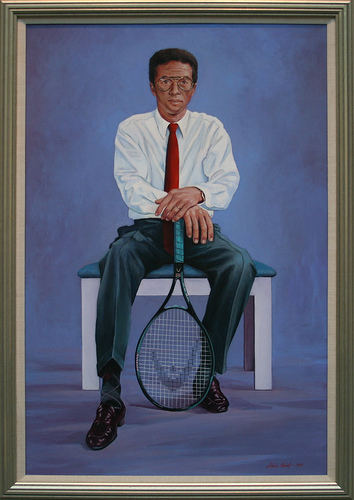Please provide a short description for this region: [0.36, 0.09, 0.63, 0.52]. A man wearing a red tie and a white shirt. 